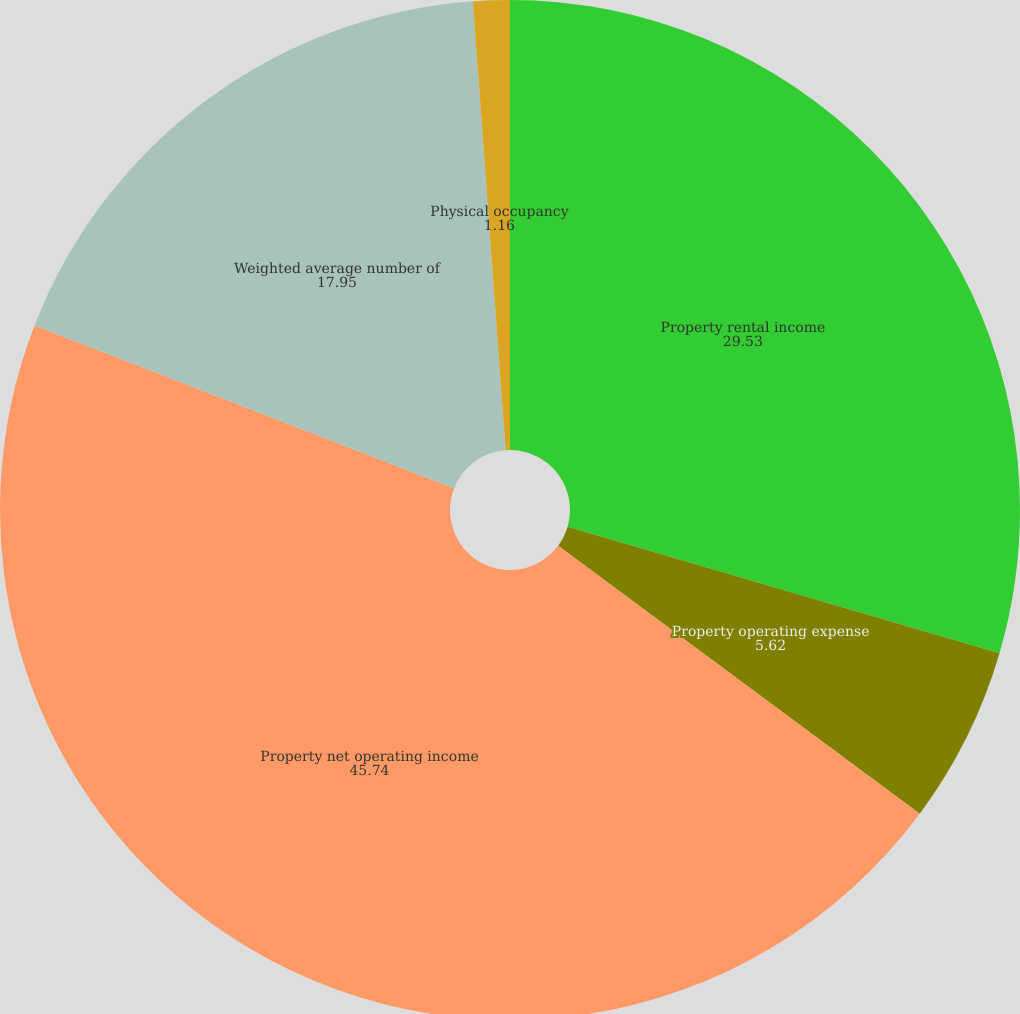Convert chart. <chart><loc_0><loc_0><loc_500><loc_500><pie_chart><fcel>Property rental income<fcel>Property operating expense<fcel>Property net operating income<fcel>Weighted average number of<fcel>Physical occupancy<nl><fcel>29.53%<fcel>5.62%<fcel>45.74%<fcel>17.95%<fcel>1.16%<nl></chart> 